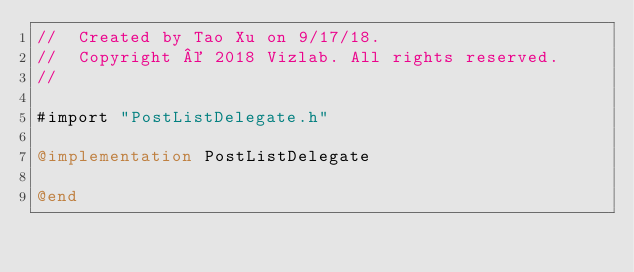Convert code to text. <code><loc_0><loc_0><loc_500><loc_500><_ObjectiveC_>//  Created by Tao Xu on 9/17/18.
//  Copyright © 2018 Vizlab. All rights reserved.
//

#import "PostListDelegate.h"

@implementation PostListDelegate

@end
</code> 